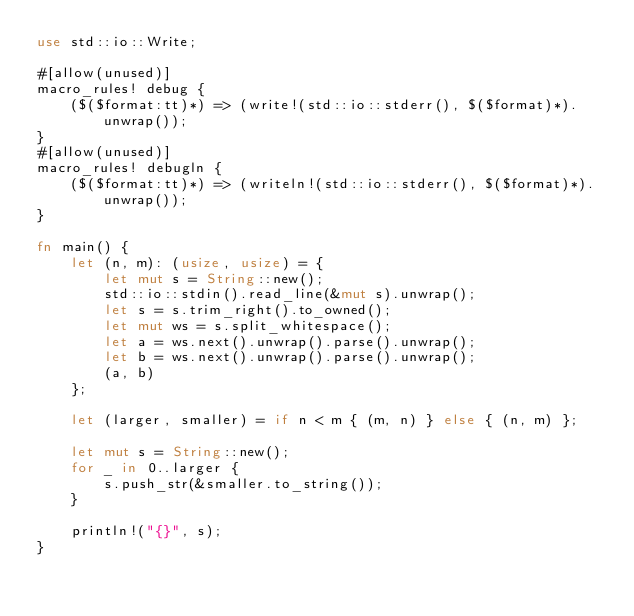Convert code to text. <code><loc_0><loc_0><loc_500><loc_500><_Rust_>use std::io::Write;

#[allow(unused)]
macro_rules! debug {
    ($($format:tt)*) => (write!(std::io::stderr(), $($format)*).unwrap());
}
#[allow(unused)]
macro_rules! debugln {
    ($($format:tt)*) => (writeln!(std::io::stderr(), $($format)*).unwrap());
}

fn main() {
    let (n, m): (usize, usize) = {
        let mut s = String::new();
        std::io::stdin().read_line(&mut s).unwrap();
        let s = s.trim_right().to_owned();
        let mut ws = s.split_whitespace();
        let a = ws.next().unwrap().parse().unwrap();
        let b = ws.next().unwrap().parse().unwrap();
        (a, b)
    };

    let (larger, smaller) = if n < m { (m, n) } else { (n, m) };

    let mut s = String::new();
    for _ in 0..larger {
        s.push_str(&smaller.to_string());
    }

    println!("{}", s);
}
</code> 